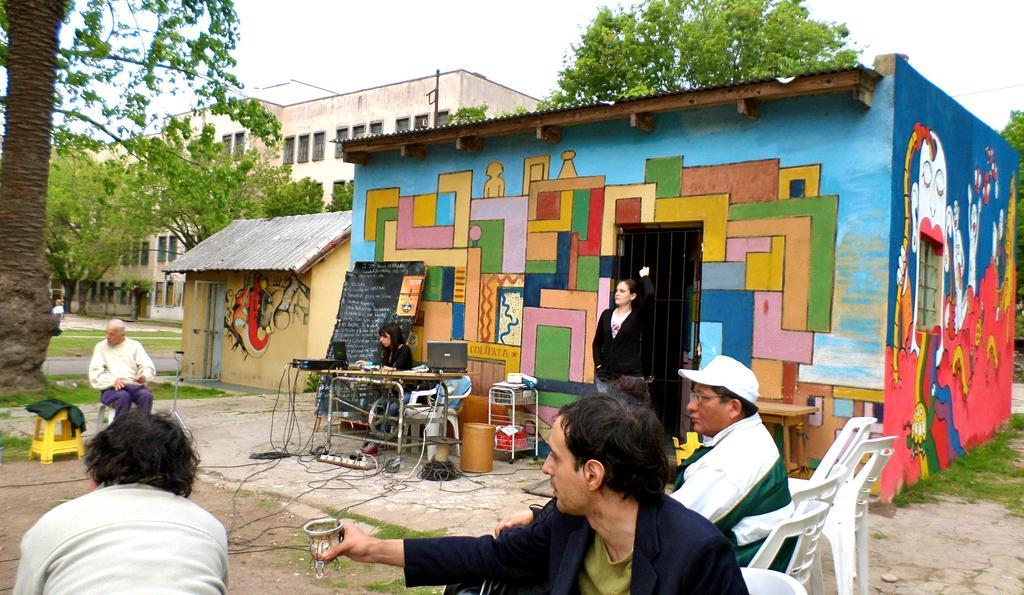Could you give a brief overview of what you see in this image? This is a picture taken in the outdoor. It is sunny. There are group of people sitting on chair. The women in black t shirt sitting on a chair in front of the women there is a table on the table there is a some system. Backside of the women there is a black board and a colorful wall and also other women in black and white t shirt stand near to the door. Background of this people is a tree, building and a sky. 